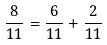<formula> <loc_0><loc_0><loc_500><loc_500>\frac { 8 } { 1 1 } = \frac { 6 } { 1 1 } + \frac { 2 } { 1 1 }</formula> 